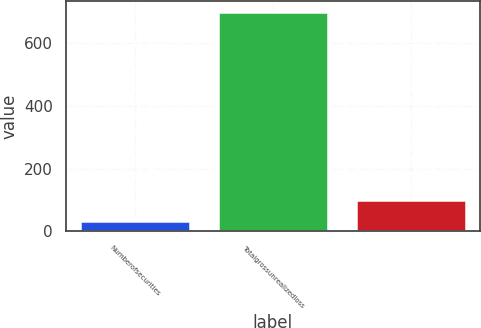Convert chart to OTSL. <chart><loc_0><loc_0><loc_500><loc_500><bar_chart><fcel>Numberofsecurities<fcel>Totalgrossunrealizedloss<fcel>Unnamed: 2<nl><fcel>33<fcel>699<fcel>99.6<nl></chart> 